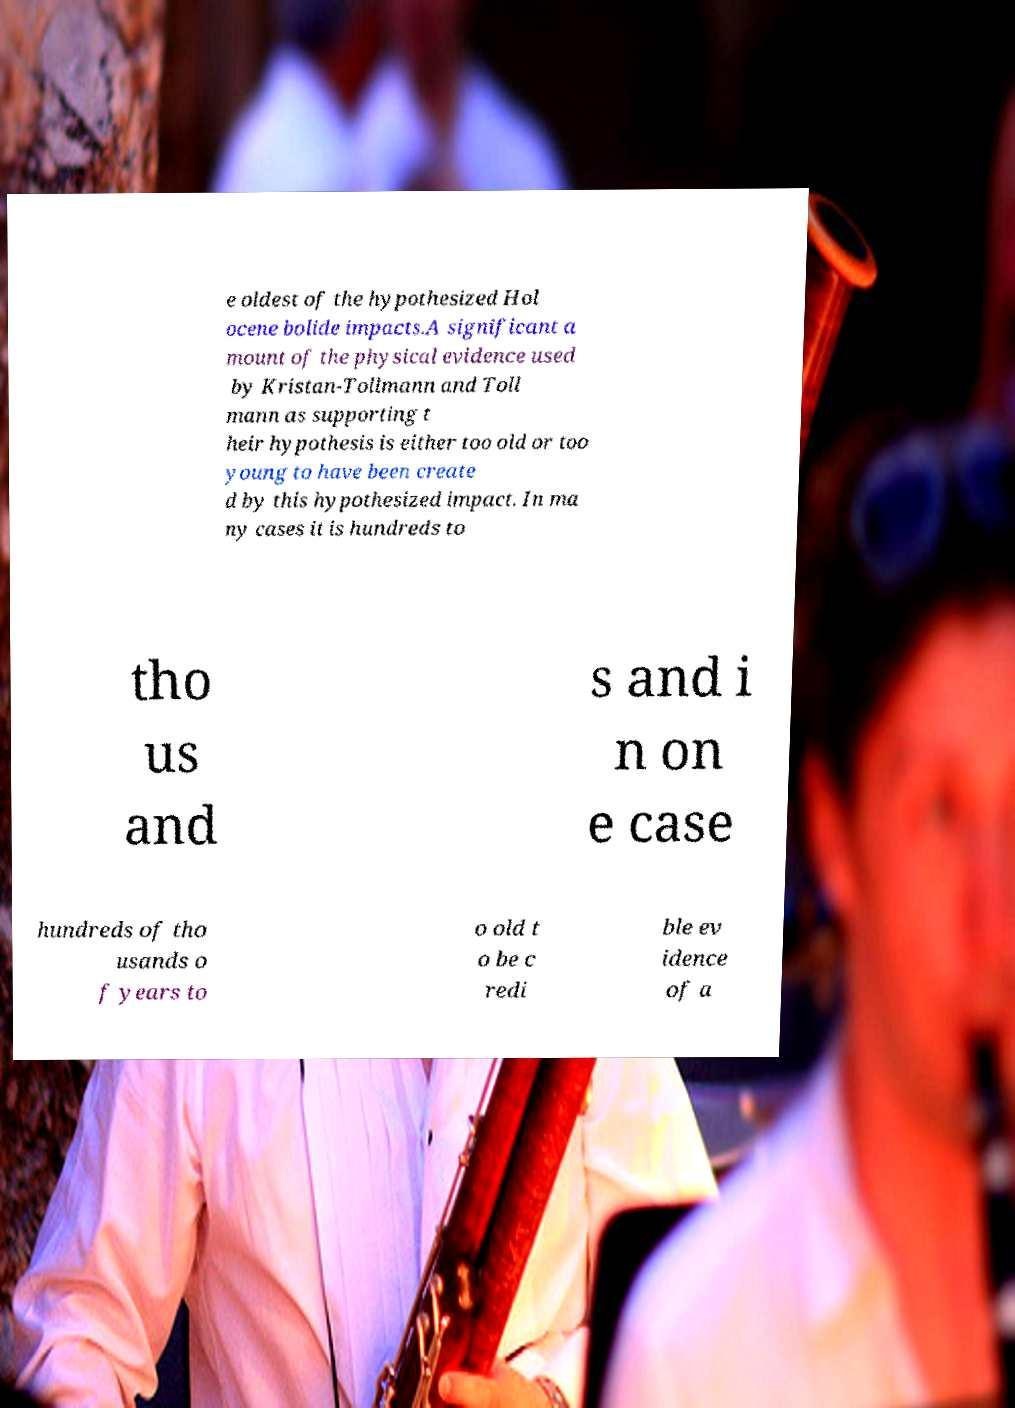Please identify and transcribe the text found in this image. e oldest of the hypothesized Hol ocene bolide impacts.A significant a mount of the physical evidence used by Kristan-Tollmann and Toll mann as supporting t heir hypothesis is either too old or too young to have been create d by this hypothesized impact. In ma ny cases it is hundreds to tho us and s and i n on e case hundreds of tho usands o f years to o old t o be c redi ble ev idence of a 